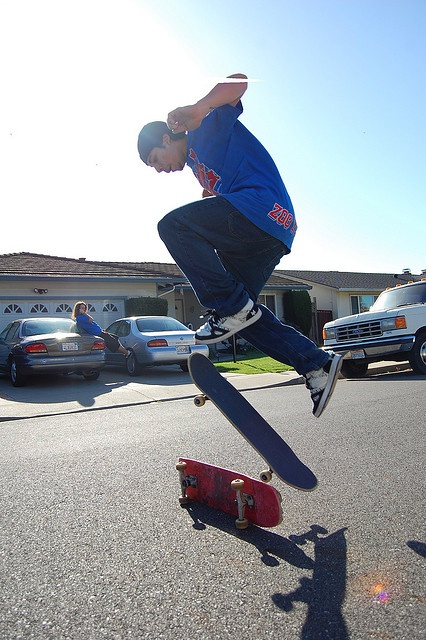Describe the objects in this image and their specific colors. I can see people in white, black, navy, gray, and darkblue tones, truck in white, black, gray, and darkgray tones, car in white, black, gray, navy, and blue tones, skateboard in white, navy, black, gray, and darkgray tones, and skateboard in white, maroon, black, gray, and purple tones in this image. 